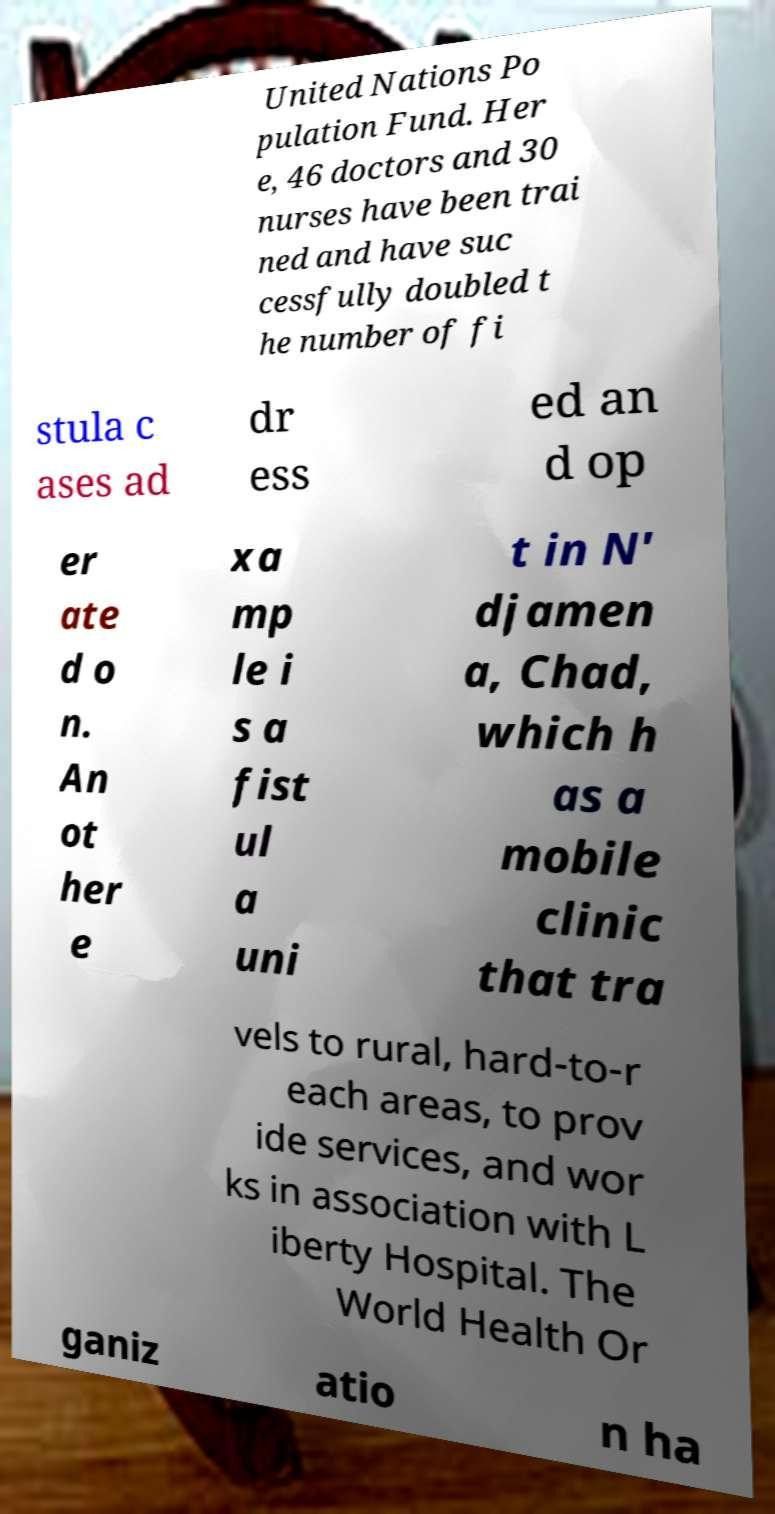Please identify and transcribe the text found in this image. United Nations Po pulation Fund. Her e, 46 doctors and 30 nurses have been trai ned and have suc cessfully doubled t he number of fi stula c ases ad dr ess ed an d op er ate d o n. An ot her e xa mp le i s a fist ul a uni t in N' djamen a, Chad, which h as a mobile clinic that tra vels to rural, hard-to-r each areas, to prov ide services, and wor ks in association with L iberty Hospital. The World Health Or ganiz atio n ha 